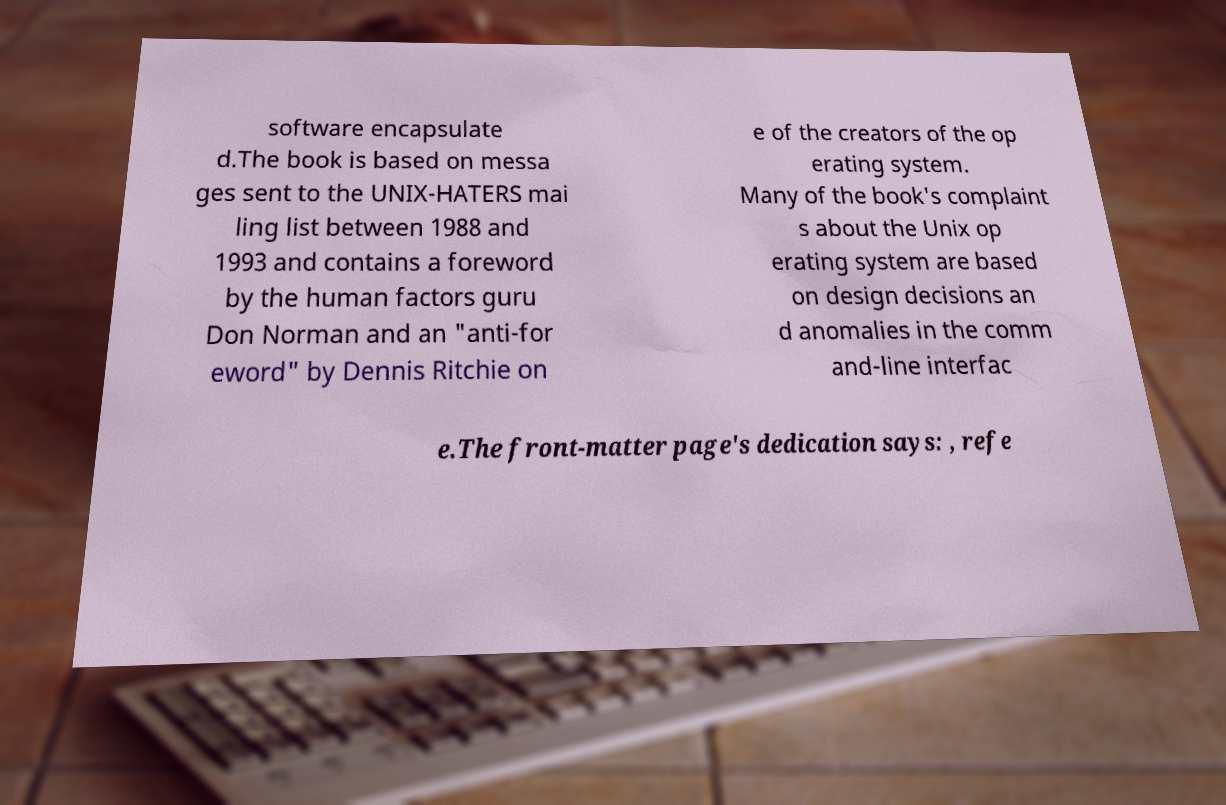There's text embedded in this image that I need extracted. Can you transcribe it verbatim? software encapsulate d.The book is based on messa ges sent to the UNIX-HATERS mai ling list between 1988 and 1993 and contains a foreword by the human factors guru Don Norman and an "anti-for eword" by Dennis Ritchie on e of the creators of the op erating system. Many of the book's complaint s about the Unix op erating system are based on design decisions an d anomalies in the comm and-line interfac e.The front-matter page's dedication says: , refe 